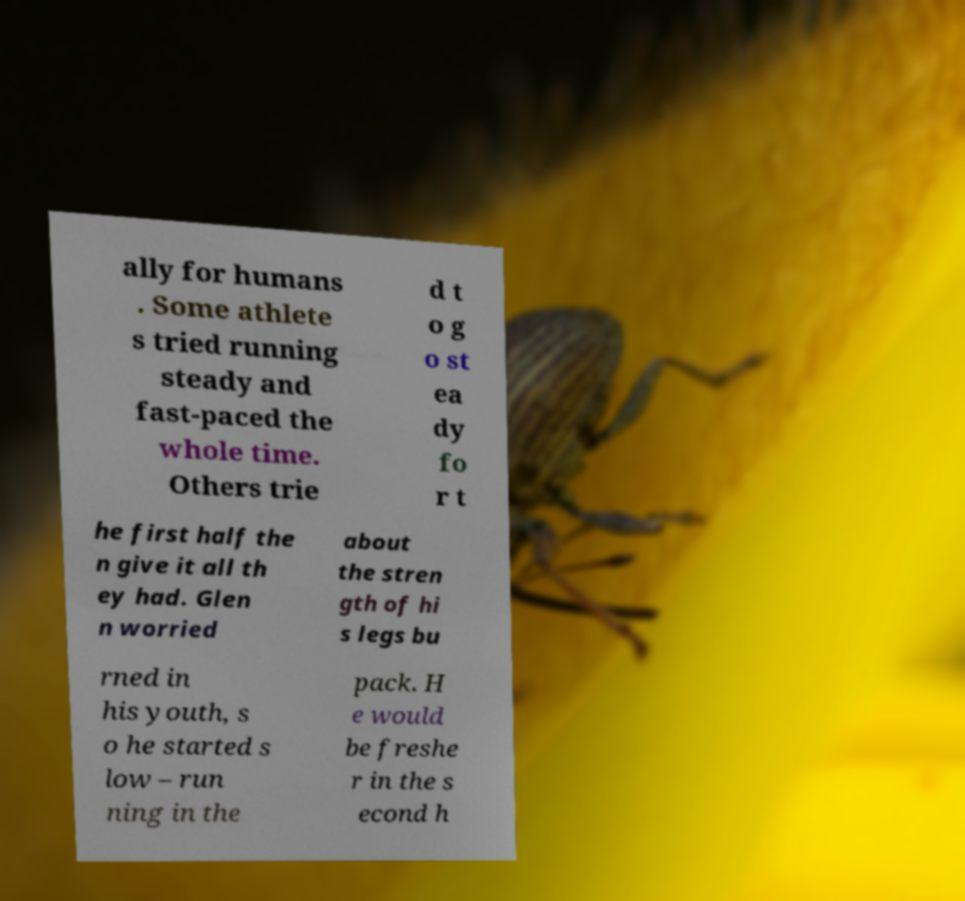What messages or text are displayed in this image? I need them in a readable, typed format. ally for humans . Some athlete s tried running steady and fast-paced the whole time. Others trie d t o g o st ea dy fo r t he first half the n give it all th ey had. Glen n worried about the stren gth of hi s legs bu rned in his youth, s o he started s low – run ning in the pack. H e would be freshe r in the s econd h 